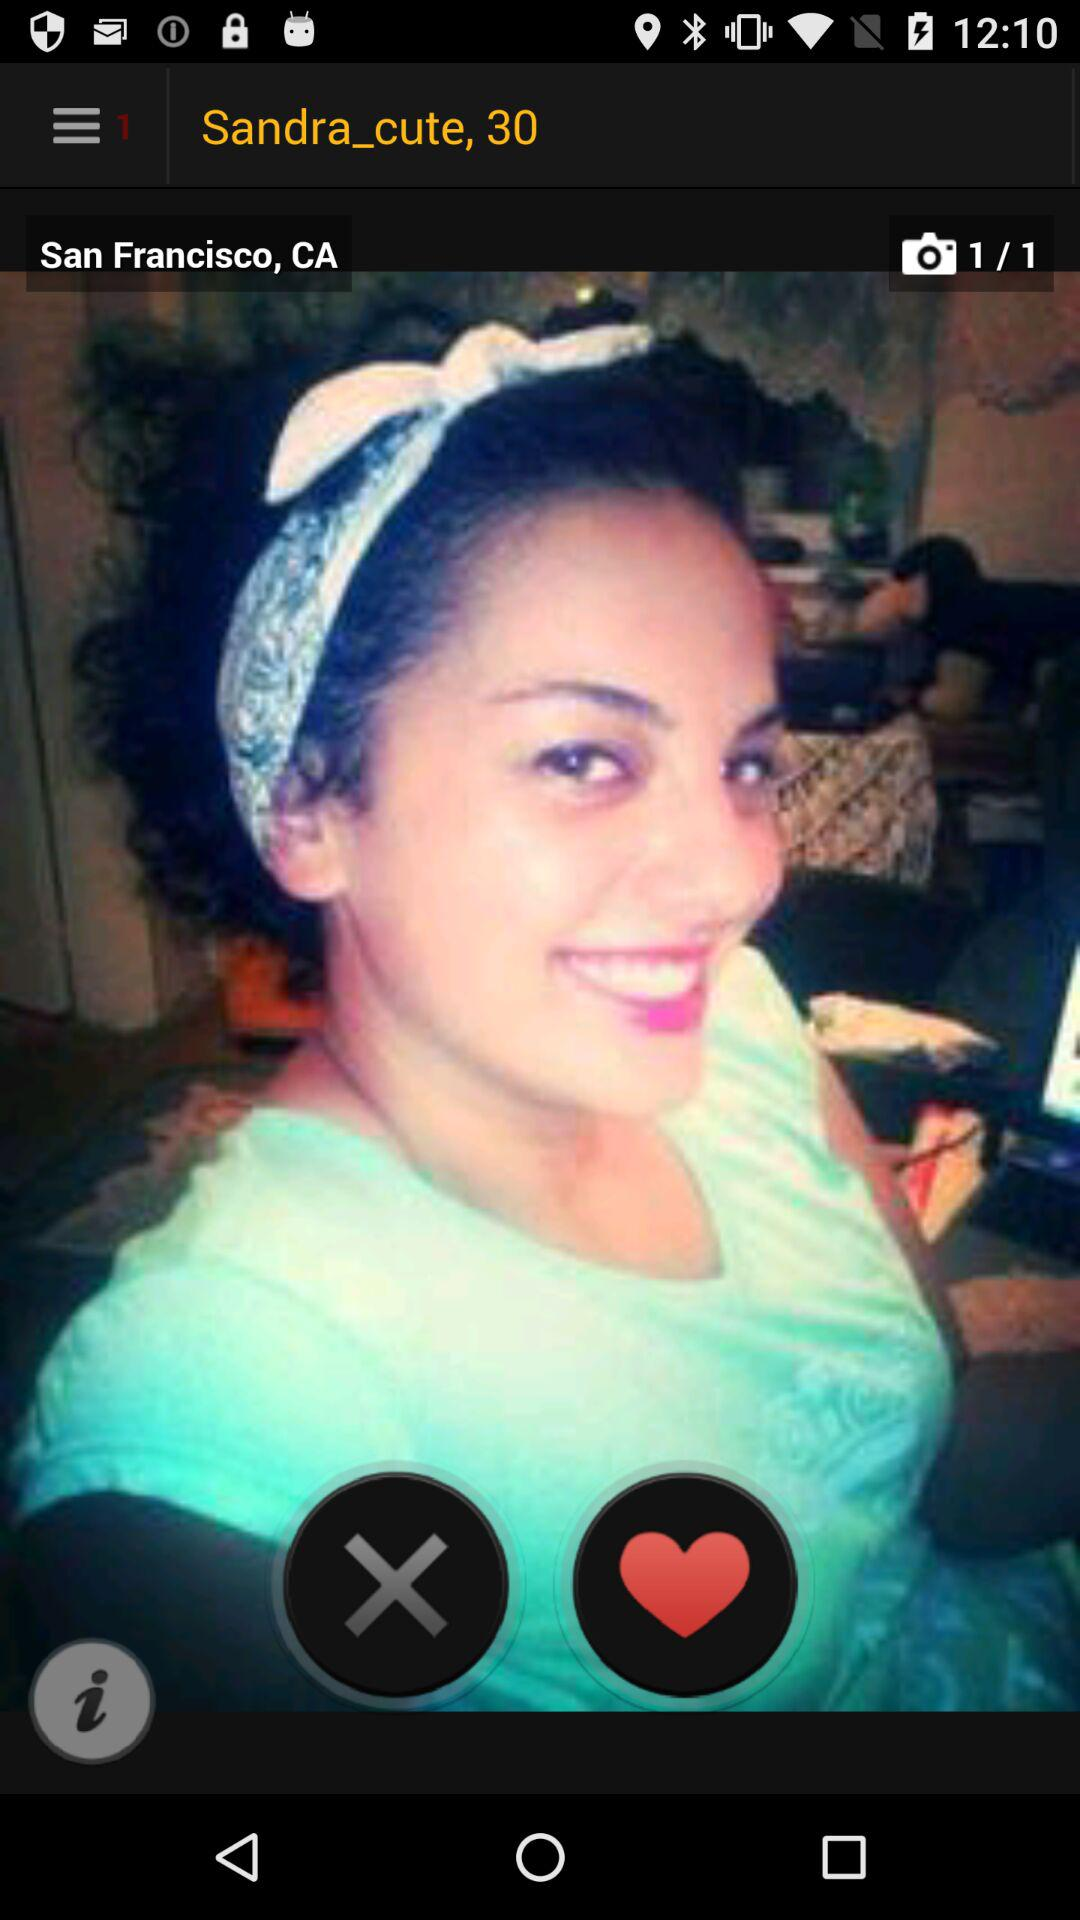What is the name of the user? The name of the user is Sandra_cute. 